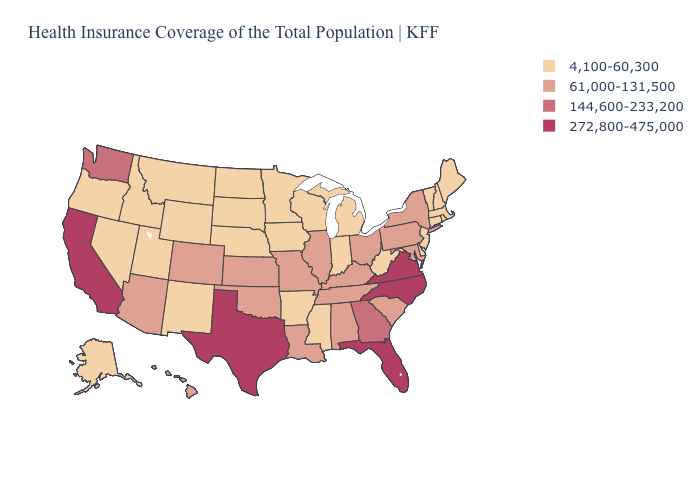Which states have the lowest value in the USA?
Quick response, please. Alaska, Arkansas, Connecticut, Delaware, Idaho, Indiana, Iowa, Maine, Massachusetts, Michigan, Minnesota, Mississippi, Montana, Nebraska, Nevada, New Hampshire, New Jersey, New Mexico, North Dakota, Oregon, Rhode Island, South Dakota, Utah, Vermont, West Virginia, Wisconsin, Wyoming. Name the states that have a value in the range 4,100-60,300?
Keep it brief. Alaska, Arkansas, Connecticut, Delaware, Idaho, Indiana, Iowa, Maine, Massachusetts, Michigan, Minnesota, Mississippi, Montana, Nebraska, Nevada, New Hampshire, New Jersey, New Mexico, North Dakota, Oregon, Rhode Island, South Dakota, Utah, Vermont, West Virginia, Wisconsin, Wyoming. What is the value of Maine?
Give a very brief answer. 4,100-60,300. What is the highest value in states that border Arkansas?
Give a very brief answer. 272,800-475,000. What is the value of Missouri?
Answer briefly. 61,000-131,500. What is the value of North Carolina?
Concise answer only. 272,800-475,000. Name the states that have a value in the range 4,100-60,300?
Keep it brief. Alaska, Arkansas, Connecticut, Delaware, Idaho, Indiana, Iowa, Maine, Massachusetts, Michigan, Minnesota, Mississippi, Montana, Nebraska, Nevada, New Hampshire, New Jersey, New Mexico, North Dakota, Oregon, Rhode Island, South Dakota, Utah, Vermont, West Virginia, Wisconsin, Wyoming. Which states hav the highest value in the South?
Quick response, please. Florida, North Carolina, Texas, Virginia. Does Maryland have a higher value than Mississippi?
Keep it brief. Yes. Does Nebraska have the same value as Georgia?
Give a very brief answer. No. What is the highest value in states that border Wyoming?
Quick response, please. 61,000-131,500. Does California have the highest value in the West?
Be succinct. Yes. Does Michigan have the same value as Hawaii?
Quick response, please. No. Name the states that have a value in the range 144,600-233,200?
Be succinct. Georgia, Washington. What is the lowest value in the West?
Concise answer only. 4,100-60,300. 